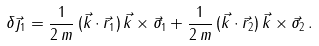<formula> <loc_0><loc_0><loc_500><loc_500>\delta \vec { \jmath } _ { 1 } = \frac { 1 } { 2 \, m } \, ( \vec { k } \cdot \vec { r } _ { 1 } ) \, \vec { k } \times \vec { \sigma } _ { 1 } + \frac { 1 } { 2 \, m } \, ( \vec { k } \cdot \vec { r } _ { 2 } ) \, \vec { k } \times \vec { \sigma } _ { 2 } \, .</formula> 